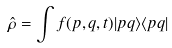<formula> <loc_0><loc_0><loc_500><loc_500>\hat { \rho } = \int f ( p , q , t ) | p q \rangle \langle p q |</formula> 